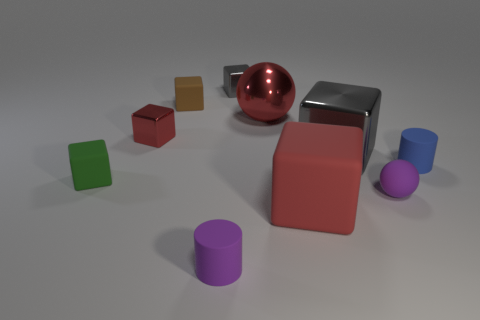Subtract all brown blocks. How many blocks are left? 5 Subtract all small red metal cubes. How many cubes are left? 5 Subtract all blue cubes. Subtract all red spheres. How many cubes are left? 6 Subtract all cylinders. How many objects are left? 8 Subtract all green matte blocks. Subtract all tiny matte spheres. How many objects are left? 8 Add 9 large red balls. How many large red balls are left? 10 Add 8 tiny gray metallic things. How many tiny gray metallic things exist? 9 Subtract 0 brown cylinders. How many objects are left? 10 